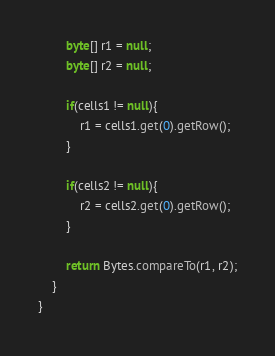Convert code to text. <code><loc_0><loc_0><loc_500><loc_500><_Java_>
        byte[] r1 = null;
        byte[] r2 = null;

        if(cells1 != null){
            r1 = cells1.get(0).getRow();
        }

        if(cells2 != null){
            r2 = cells2.get(0).getRow();
        }

        return Bytes.compareTo(r1, r2);
    }
}
</code> 